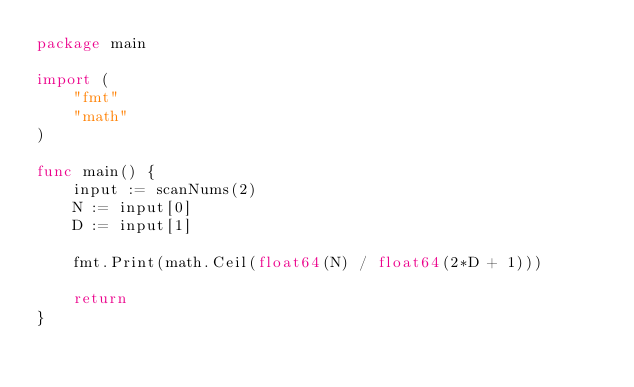<code> <loc_0><loc_0><loc_500><loc_500><_Go_>package main

import (
	"fmt"
	"math"
)

func main() {
	input := scanNums(2)
	N := input[0]
	D := input[1]

	fmt.Print(math.Ceil(float64(N) / float64(2*D + 1)))

	return
}</code> 